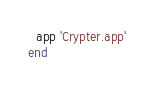Convert code to text. <code><loc_0><loc_0><loc_500><loc_500><_Ruby_>  app 'Crypter.app'
end
</code> 